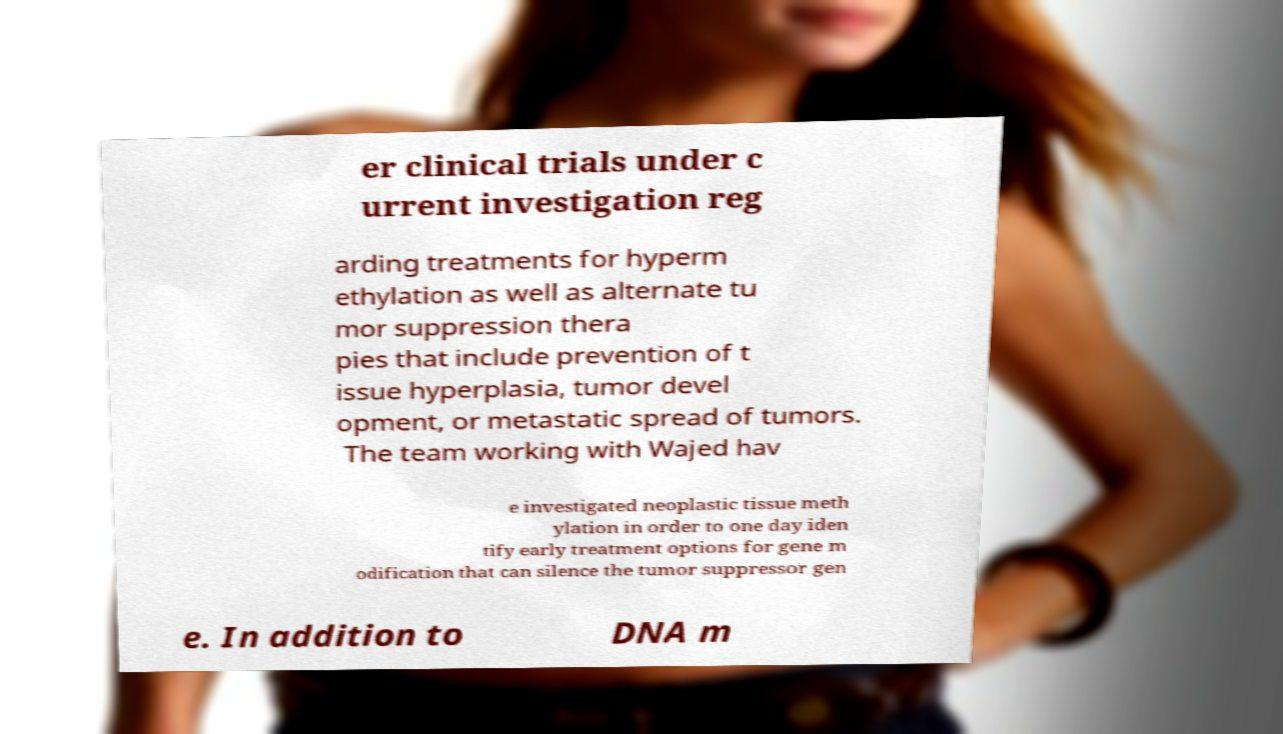There's text embedded in this image that I need extracted. Can you transcribe it verbatim? er clinical trials under c urrent investigation reg arding treatments for hyperm ethylation as well as alternate tu mor suppression thera pies that include prevention of t issue hyperplasia, tumor devel opment, or metastatic spread of tumors. The team working with Wajed hav e investigated neoplastic tissue meth ylation in order to one day iden tify early treatment options for gene m odification that can silence the tumor suppressor gen e. In addition to DNA m 